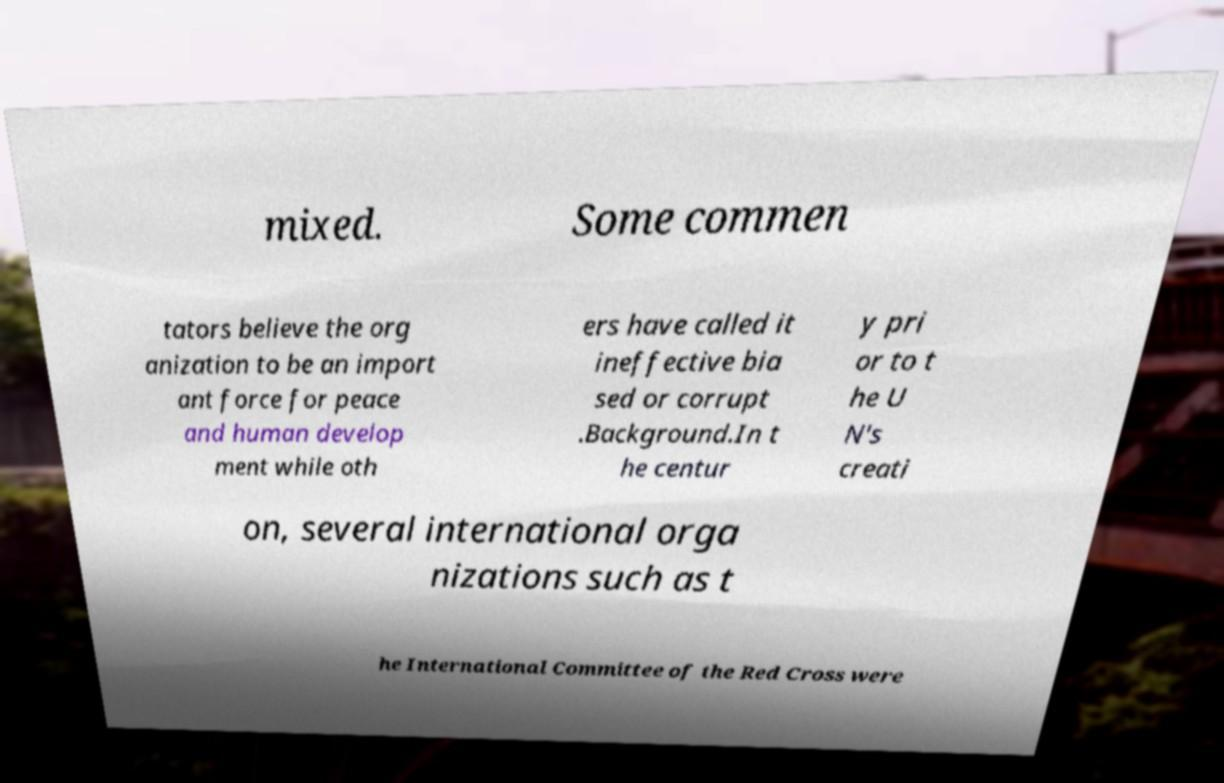There's text embedded in this image that I need extracted. Can you transcribe it verbatim? mixed. Some commen tators believe the org anization to be an import ant force for peace and human develop ment while oth ers have called it ineffective bia sed or corrupt .Background.In t he centur y pri or to t he U N's creati on, several international orga nizations such as t he International Committee of the Red Cross were 